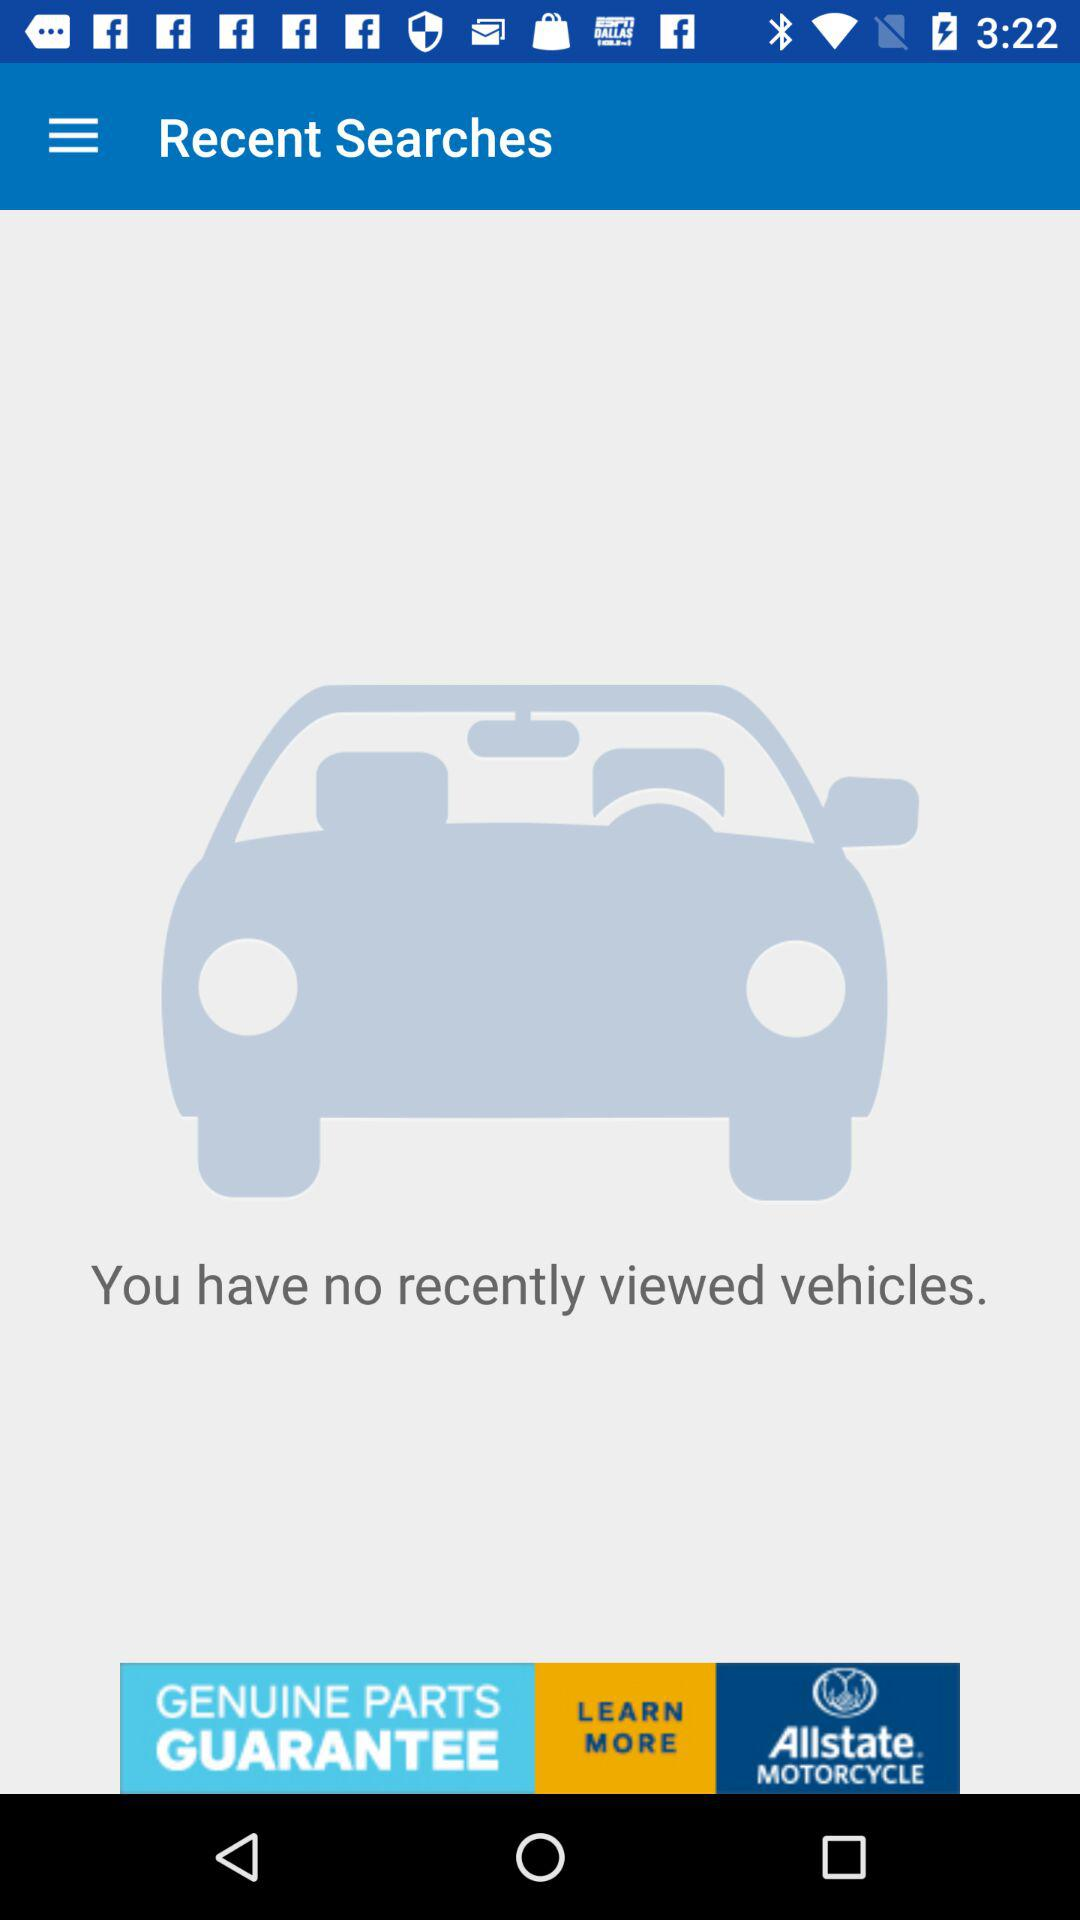Do I have recently viewed vehicles? You have no recently viewed vehicles. 